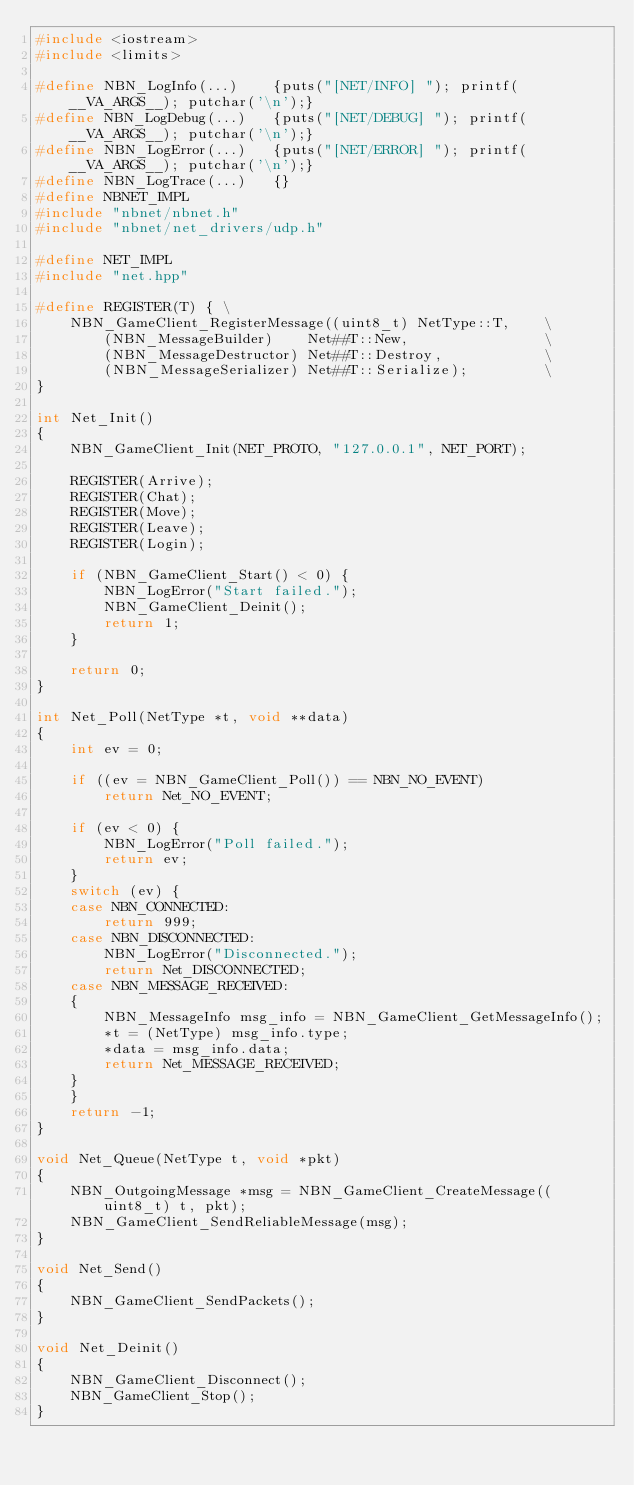Convert code to text. <code><loc_0><loc_0><loc_500><loc_500><_C++_>#include <iostream>
#include <limits>

#define NBN_LogInfo(...)    {puts("[NET/INFO] "); printf(__VA_ARGS__); putchar('\n');}
#define NBN_LogDebug(...)   {puts("[NET/DEBUG] "); printf(__VA_ARGS__); putchar('\n');}
#define NBN_LogError(...)   {puts("[NET/ERROR] "); printf(__VA_ARGS__); putchar('\n');}
#define NBN_LogTrace(...)   {}
#define NBNET_IMPL
#include "nbnet/nbnet.h"
#include "nbnet/net_drivers/udp.h"

#define NET_IMPL
#include "net.hpp"

#define REGISTER(T) { \
    NBN_GameClient_RegisterMessage((uint8_t) NetType::T,    \
        (NBN_MessageBuilder)    Net##T::New,                \
        (NBN_MessageDestructor) Net##T::Destroy,            \
        (NBN_MessageSerializer) Net##T::Serialize);         \
}

int Net_Init()
{
    NBN_GameClient_Init(NET_PROTO, "127.0.0.1", NET_PORT);

    REGISTER(Arrive);
    REGISTER(Chat);
    REGISTER(Move);
    REGISTER(Leave);
    REGISTER(Login);

    if (NBN_GameClient_Start() < 0) {
        NBN_LogError("Start failed.");
        NBN_GameClient_Deinit();
        return 1;
    }

    return 0;
}

int Net_Poll(NetType *t, void **data)
{
    int ev = 0;

    if ((ev = NBN_GameClient_Poll()) == NBN_NO_EVENT)
        return Net_NO_EVENT;

    if (ev < 0) {
        NBN_LogError("Poll failed.");
        return ev;
    }
    switch (ev) {
    case NBN_CONNECTED:
        return 999;
    case NBN_DISCONNECTED:
        NBN_LogError("Disconnected.");
        return Net_DISCONNECTED;
    case NBN_MESSAGE_RECEIVED:
    {
        NBN_MessageInfo msg_info = NBN_GameClient_GetMessageInfo();
        *t = (NetType) msg_info.type;
        *data = msg_info.data;
        return Net_MESSAGE_RECEIVED;
    }
    }
    return -1;
}

void Net_Queue(NetType t, void *pkt)
{
    NBN_OutgoingMessage *msg = NBN_GameClient_CreateMessage((uint8_t) t, pkt);
    NBN_GameClient_SendReliableMessage(msg);
}

void Net_Send()
{
    NBN_GameClient_SendPackets();
}

void Net_Deinit()
{
    NBN_GameClient_Disconnect();
    NBN_GameClient_Stop();
}
</code> 